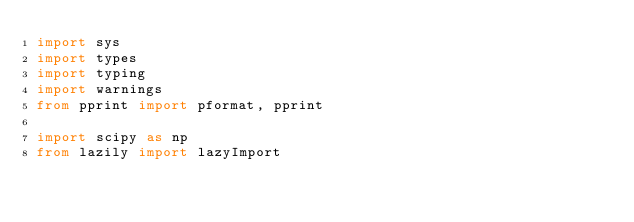Convert code to text. <code><loc_0><loc_0><loc_500><loc_500><_Python_>import sys
import types
import typing
import warnings
from pprint import pformat, pprint

import scipy as np
from lazily import lazyImport
</code> 